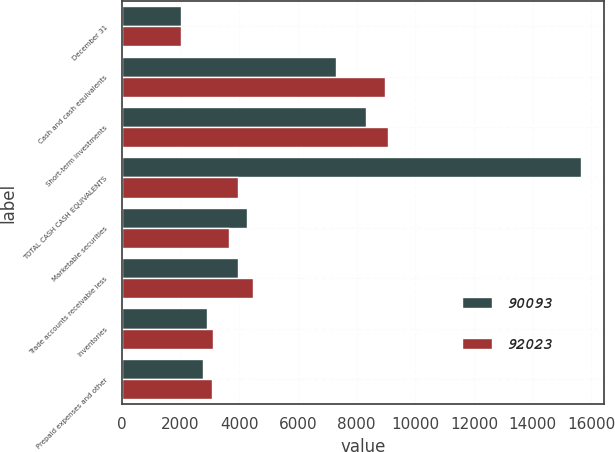<chart> <loc_0><loc_0><loc_500><loc_500><stacked_bar_chart><ecel><fcel>December 31<fcel>Cash and cash equivalents<fcel>Short-term investments<fcel>TOTAL CASH CASH EQUIVALENTS<fcel>Marketable securities<fcel>Trade accounts receivable less<fcel>Inventories<fcel>Prepaid expenses and other<nl><fcel>90093<fcel>2015<fcel>7309<fcel>8322<fcel>15631<fcel>4269<fcel>3941<fcel>2902<fcel>2752<nl><fcel>92023<fcel>2014<fcel>8958<fcel>9052<fcel>3941<fcel>3665<fcel>4466<fcel>3100<fcel>3066<nl></chart> 